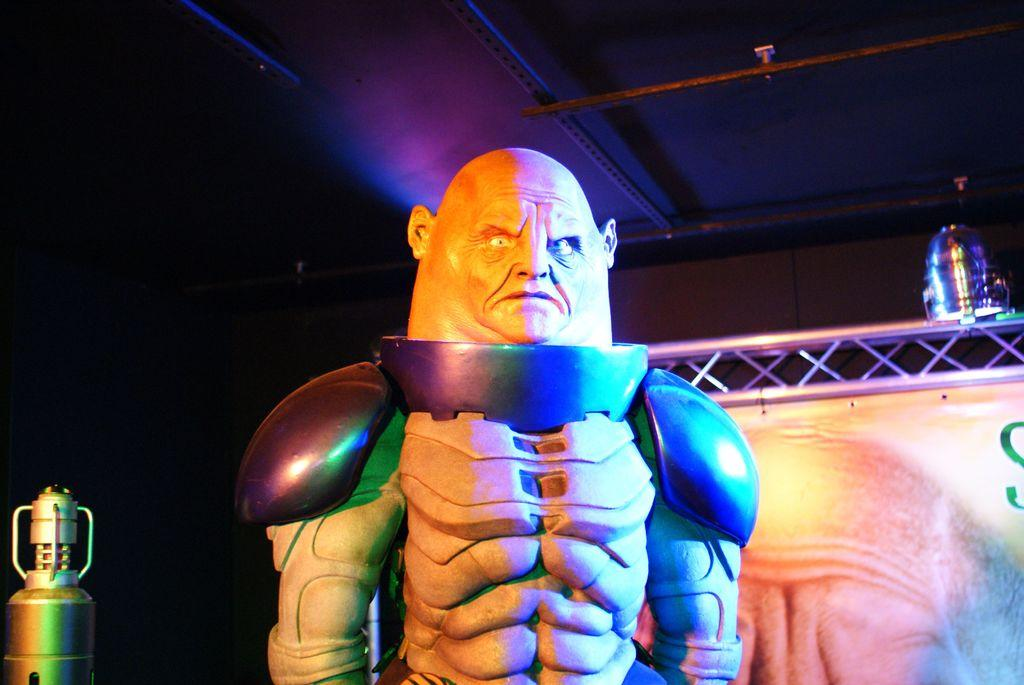What is the main subject in the foreground of the image? There is a statue-like structure in the foreground of the image. What can be seen in the background of the image? There is a banner and a light in the background of the image. Can you describe the object on the left side of the image? There is an object on the left side of the image, but its specific details are not mentioned in the provided facts. What type of tooth is the statue holding in the image? There is no tooth present in the image; the main subject is a statue-like structure. 